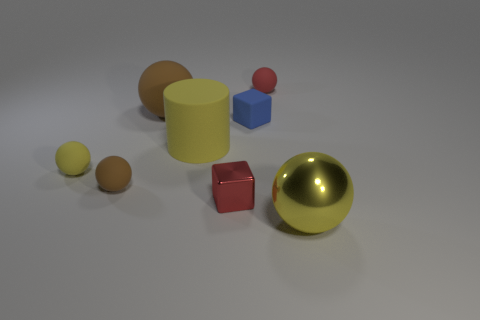What is the material of the cube that is the same size as the blue thing?
Offer a very short reply. Metal. There is a rubber thing that is to the right of the red metallic object and behind the matte block; what size is it?
Give a very brief answer. Small. What is the size of the yellow matte thing that is the same shape as the small brown rubber thing?
Your answer should be very brief. Small. What number of objects are blue things or large things that are left of the red block?
Your answer should be very brief. 3. The small brown object is what shape?
Provide a succinct answer. Sphere. The large yellow object that is to the right of the big yellow matte thing to the right of the small brown rubber object is what shape?
Ensure brevity in your answer.  Sphere. There is another large object that is the same color as the big metallic thing; what is it made of?
Offer a very short reply. Rubber. The cube that is the same material as the small yellow ball is what color?
Offer a very short reply. Blue. Is the color of the shiny thing behind the large yellow metallic object the same as the matte ball that is behind the big matte sphere?
Your answer should be compact. Yes. Are there more matte spheres that are behind the matte cylinder than large yellow metal balls that are to the left of the tiny red shiny object?
Give a very brief answer. Yes. 